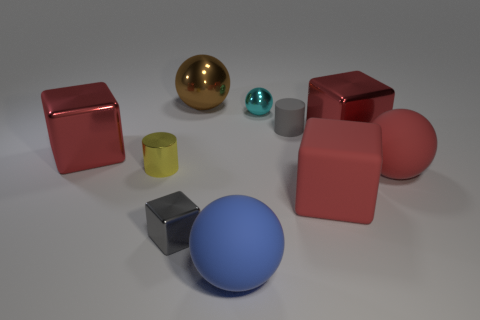Is the color of the shiny object in front of the rubber block the same as the cylinder on the left side of the large metallic sphere?
Your response must be concise. No. How many metal things are big balls or small cyan balls?
Provide a succinct answer. 2. Are there any other things that are the same size as the blue thing?
Provide a short and direct response. Yes. There is a red shiny object that is on the left side of the tiny gray object right of the gray metallic object; what shape is it?
Provide a short and direct response. Cube. Do the red object that is to the left of the blue rubber thing and the cylinder that is on the right side of the yellow metallic thing have the same material?
Make the answer very short. No. There is a large red metallic object left of the small gray matte cylinder; how many red blocks are behind it?
Provide a short and direct response. 1. Do the red shiny thing left of the small cyan shiny sphere and the large red metal thing right of the tiny gray matte cylinder have the same shape?
Your answer should be compact. Yes. What size is the cube that is both behind the gray block and in front of the tiny yellow cylinder?
Your answer should be very brief. Large. What color is the tiny shiny object that is the same shape as the small rubber object?
Make the answer very short. Yellow. What is the color of the big sphere behind the big cube to the left of the yellow cylinder?
Provide a short and direct response. Brown. 